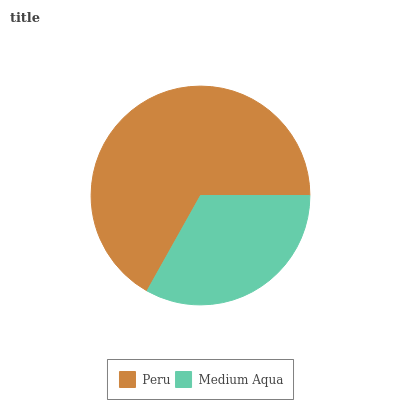Is Medium Aqua the minimum?
Answer yes or no. Yes. Is Peru the maximum?
Answer yes or no. Yes. Is Medium Aqua the maximum?
Answer yes or no. No. Is Peru greater than Medium Aqua?
Answer yes or no. Yes. Is Medium Aqua less than Peru?
Answer yes or no. Yes. Is Medium Aqua greater than Peru?
Answer yes or no. No. Is Peru less than Medium Aqua?
Answer yes or no. No. Is Peru the high median?
Answer yes or no. Yes. Is Medium Aqua the low median?
Answer yes or no. Yes. Is Medium Aqua the high median?
Answer yes or no. No. Is Peru the low median?
Answer yes or no. No. 